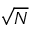Convert formula to latex. <formula><loc_0><loc_0><loc_500><loc_500>\sqrt { N }</formula> 